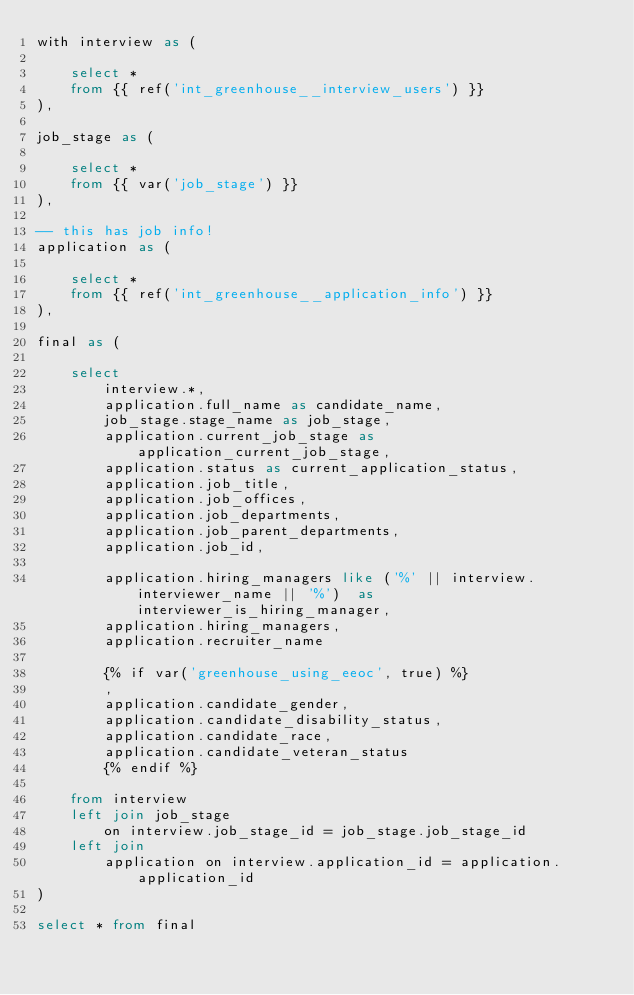<code> <loc_0><loc_0><loc_500><loc_500><_SQL_>with interview as (

    select *
    from {{ ref('int_greenhouse__interview_users') }}
),

job_stage as (

    select *
    from {{ var('job_stage') }}
),

-- this has job info!
application as (

    select *
    from {{ ref('int_greenhouse__application_info') }}
),

final as (

    select
        interview.*,
        application.full_name as candidate_name,
        job_stage.stage_name as job_stage,
        application.current_job_stage as application_current_job_stage,
        application.status as current_application_status,
        application.job_title,
        application.job_offices,
        application.job_departments,
        application.job_parent_departments,
        application.job_id,

        application.hiring_managers like ('%' || interview.interviewer_name || '%')  as interviewer_is_hiring_manager,
        application.hiring_managers,
        application.recruiter_name

        {% if var('greenhouse_using_eeoc', true) %}
        ,
        application.candidate_gender,
        application.candidate_disability_status,
        application.candidate_race,
        application.candidate_veteran_status
        {% endif %}

    from interview
    left join job_stage 
        on interview.job_stage_id = job_stage.job_stage_id
    left join 
        application on interview.application_id = application.application_id
)

select * from final</code> 